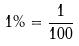<formula> <loc_0><loc_0><loc_500><loc_500>1 \% = \frac { 1 } { 1 0 0 }</formula> 